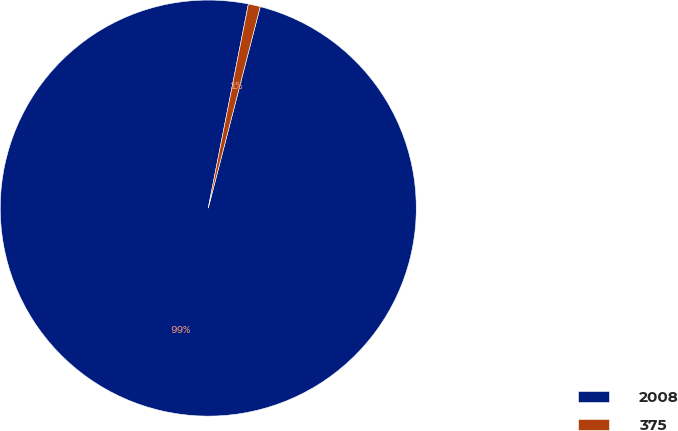<chart> <loc_0><loc_0><loc_500><loc_500><pie_chart><fcel>2008<fcel>375<nl><fcel>99.07%<fcel>0.93%<nl></chart> 